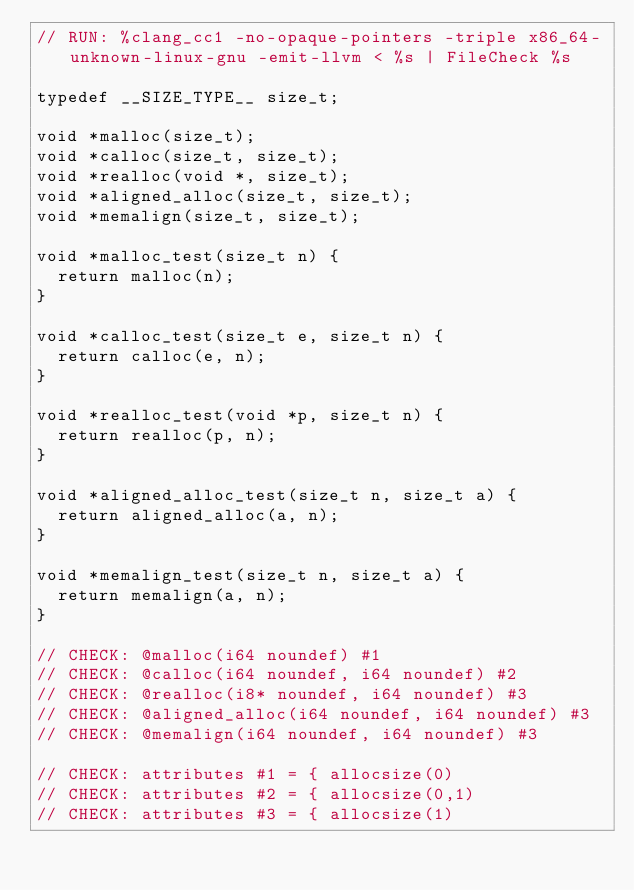<code> <loc_0><loc_0><loc_500><loc_500><_C_>// RUN: %clang_cc1 -no-opaque-pointers -triple x86_64-unknown-linux-gnu -emit-llvm < %s | FileCheck %s

typedef __SIZE_TYPE__ size_t;

void *malloc(size_t);
void *calloc(size_t, size_t);
void *realloc(void *, size_t);
void *aligned_alloc(size_t, size_t);
void *memalign(size_t, size_t);

void *malloc_test(size_t n) {
  return malloc(n);
}

void *calloc_test(size_t e, size_t n) {
  return calloc(e, n);
}

void *realloc_test(void *p, size_t n) {
  return realloc(p, n);
}

void *aligned_alloc_test(size_t n, size_t a) {
  return aligned_alloc(a, n);
}

void *memalign_test(size_t n, size_t a) {
  return memalign(a, n);
}

// CHECK: @malloc(i64 noundef) #1
// CHECK: @calloc(i64 noundef, i64 noundef) #2
// CHECK: @realloc(i8* noundef, i64 noundef) #3
// CHECK: @aligned_alloc(i64 noundef, i64 noundef) #3
// CHECK: @memalign(i64 noundef, i64 noundef) #3

// CHECK: attributes #1 = { allocsize(0)
// CHECK: attributes #2 = { allocsize(0,1)
// CHECK: attributes #3 = { allocsize(1)
</code> 